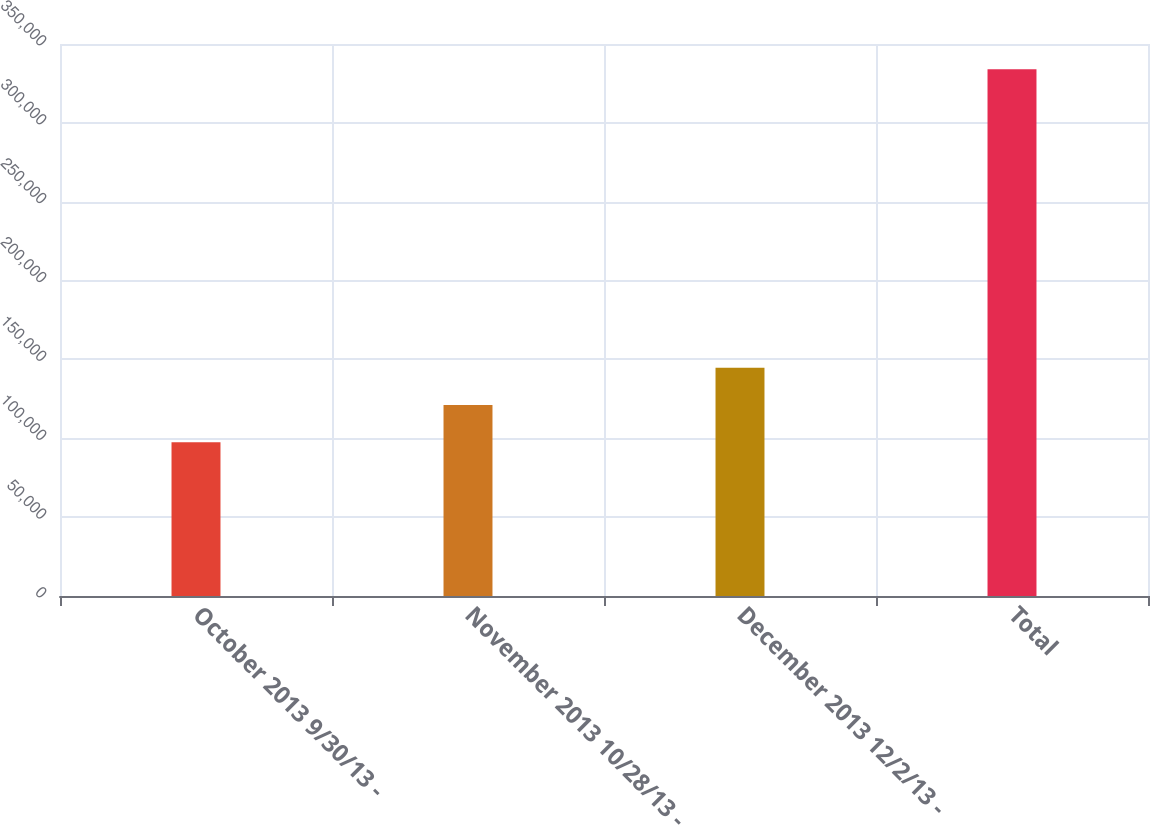Convert chart to OTSL. <chart><loc_0><loc_0><loc_500><loc_500><bar_chart><fcel>October 2013 9/30/13 -<fcel>November 2013 10/28/13 -<fcel>December 2013 12/2/13 -<fcel>Total<nl><fcel>97500<fcel>121150<fcel>144800<fcel>334000<nl></chart> 